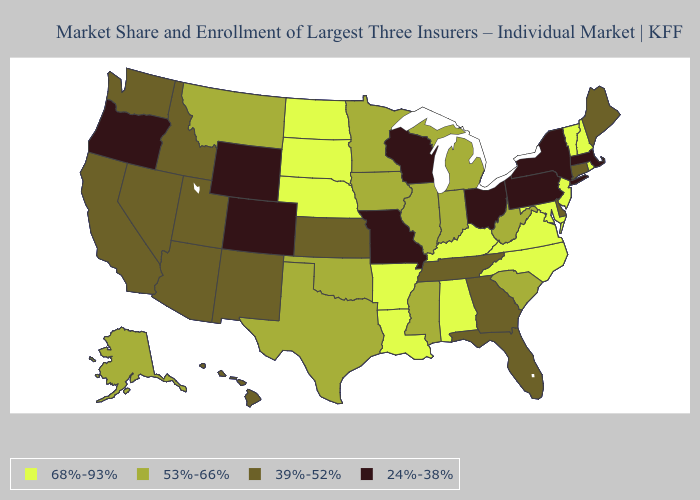What is the value of Wyoming?
Write a very short answer. 24%-38%. Name the states that have a value in the range 24%-38%?
Concise answer only. Colorado, Massachusetts, Missouri, New York, Ohio, Oregon, Pennsylvania, Wisconsin, Wyoming. Does Alabama have the highest value in the USA?
Short answer required. Yes. Name the states that have a value in the range 39%-52%?
Short answer required. Arizona, California, Connecticut, Delaware, Florida, Georgia, Hawaii, Idaho, Kansas, Maine, Nevada, New Mexico, Tennessee, Utah, Washington. Does New York have the highest value in the Northeast?
Answer briefly. No. Does New York have the lowest value in the USA?
Give a very brief answer. Yes. Name the states that have a value in the range 24%-38%?
Write a very short answer. Colorado, Massachusetts, Missouri, New York, Ohio, Oregon, Pennsylvania, Wisconsin, Wyoming. Does Idaho have a higher value than Ohio?
Answer briefly. Yes. What is the value of Nebraska?
Write a very short answer. 68%-93%. Does Maryland have the highest value in the USA?
Answer briefly. Yes. Name the states that have a value in the range 53%-66%?
Be succinct. Alaska, Illinois, Indiana, Iowa, Michigan, Minnesota, Mississippi, Montana, Oklahoma, South Carolina, Texas, West Virginia. Name the states that have a value in the range 24%-38%?
Write a very short answer. Colorado, Massachusetts, Missouri, New York, Ohio, Oregon, Pennsylvania, Wisconsin, Wyoming. Which states have the lowest value in the West?
Concise answer only. Colorado, Oregon, Wyoming. Is the legend a continuous bar?
Short answer required. No. Name the states that have a value in the range 24%-38%?
Answer briefly. Colorado, Massachusetts, Missouri, New York, Ohio, Oregon, Pennsylvania, Wisconsin, Wyoming. 